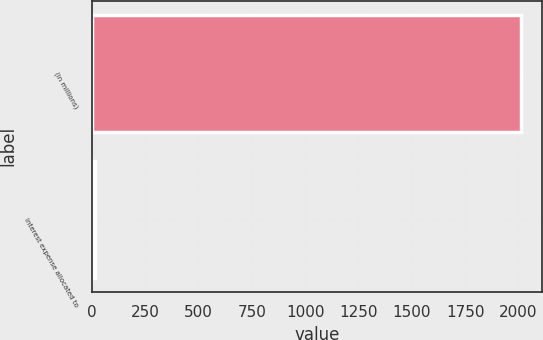Convert chart. <chart><loc_0><loc_0><loc_500><loc_500><bar_chart><fcel>(in millions)<fcel>Interest expense allocated to<nl><fcel>2010<fcel>12.8<nl></chart> 